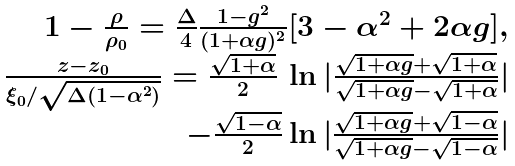<formula> <loc_0><loc_0><loc_500><loc_500>\begin{array} { r } 1 - \frac { \rho } { \rho _ { 0 } } = \frac { \Delta } { 4 } \frac { 1 - g ^ { 2 } } { ( 1 + \alpha g ) ^ { 2 } } [ 3 - \alpha ^ { 2 } + 2 \alpha g ] , \\ \frac { z - z _ { 0 } } { \xi _ { 0 } / \sqrt { \Delta ( 1 - \alpha ^ { 2 } ) } } = \frac { \sqrt { 1 + \alpha } } { 2 } \, \ln | \frac { \sqrt { 1 + \alpha g } + \sqrt { 1 + \alpha } } { \sqrt { 1 + \alpha g } - \sqrt { 1 + \alpha } } | \\ - \frac { \sqrt { 1 - \alpha } } { 2 } \ln | \frac { \sqrt { 1 + \alpha g } + \sqrt { 1 - \alpha } } { \sqrt { 1 + \alpha g } - \sqrt { 1 - \alpha } } | \end{array}</formula> 